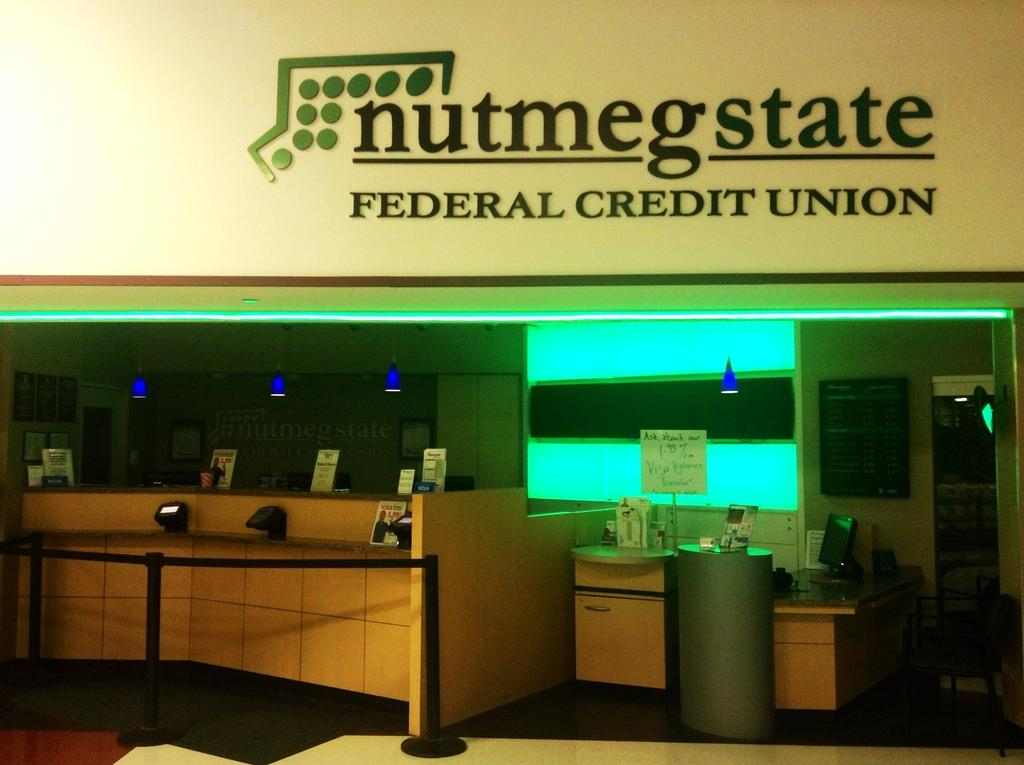<image>
Give a short and clear explanation of the subsequent image. A branch of a Federal credit union shown. 